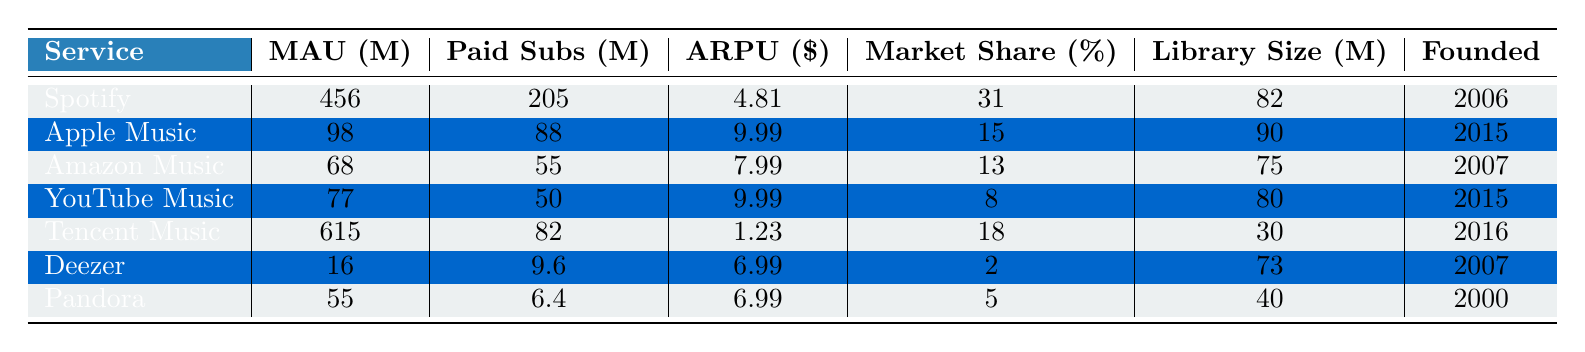What is the market share of Spotify? The table shows that the market share of Spotify is listed as 31%.
Answer: 31% How many monthly active users does Apple Music have? The table indicates that Apple Music has 98 million monthly active users.
Answer: 98 million Which service has the highest average revenue per user (ARPU)? By comparing the ARPU values in the table, Apple Music and YouTube Music both have an ARPU of $9.99, which is the highest among the listed services.
Answer: Apple Music and YouTube Music What is the total number of paid subscribers for all listed services? Summing the paid subscribers: 205 + 88 + 55 + 50 + 82 + 9.6 + 6.4 = 496 million.
Answer: 496 million Is the content library size of Deezer larger than that of Amazon Music? Deezer has a content library of 73 million, while Amazon Music has 75 million; therefore, Deezer's library is not larger.
Answer: No What is the difference in monthly active users between Tencent Music and Spotify? Tencent Music has 615 million users, while Spotify has 456 million. The difference is 615 - 456 = 159 million.
Answer: 159 million Which service was founded first, Pandora or Deezer? The table shows that Pandora was founded in 2000 and Deezer in 2007, so Pandora was founded first.
Answer: Pandora If we average the average revenue per user for all services, what do we get? The ARPUs are: 4.81, 9.99, 7.99, 9.99, 1.23, 6.99, and 6.99. Summing them gives 47.22, and dividing by 7 services (47.22 / 7) gives approximately 6.74.
Answer: 6.74 Does Amazon Music have more monthly active users than Deezer? Amazon Music has 68 million users and Deezer has 16 million, indicating that Amazon Music has more users.
Answer: Yes Which service has the lowest market share? The table indicates that Deezer has the lowest market share at 2%.
Answer: 2% 